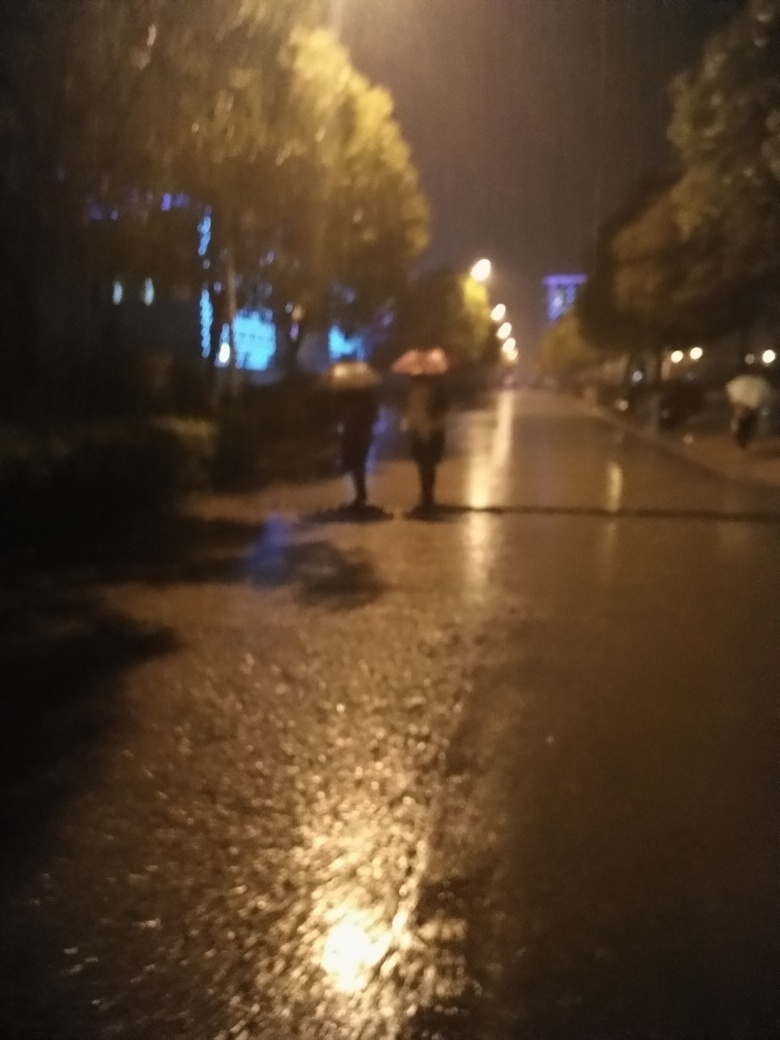How would you describe the quality of this image? The quality of the image is quite low due to significant blur and poor light conditions, which obscure details and render the scene indistinct. It seems to be taken in low-light conditions, possibly during nighttime with wet ground reflecting some light, suggesting recent rain. The lack of sharpness might be attributed to camera shake or the subject's movement. 